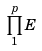<formula> <loc_0><loc_0><loc_500><loc_500>\prod _ { 1 } ^ { p } E</formula> 